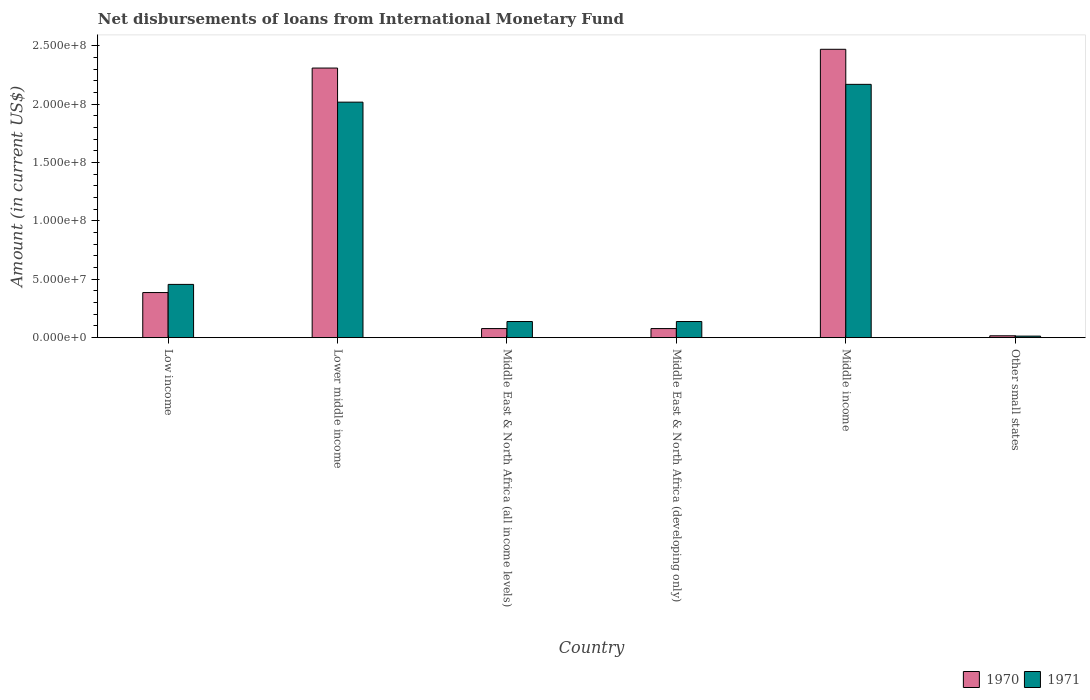How many different coloured bars are there?
Your response must be concise. 2. How many groups of bars are there?
Offer a very short reply. 6. Are the number of bars per tick equal to the number of legend labels?
Your answer should be very brief. Yes. Are the number of bars on each tick of the X-axis equal?
Ensure brevity in your answer.  Yes. How many bars are there on the 1st tick from the left?
Your answer should be compact. 2. How many bars are there on the 5th tick from the right?
Make the answer very short. 2. What is the label of the 6th group of bars from the left?
Make the answer very short. Other small states. What is the amount of loans disbursed in 1971 in Other small states?
Provide a succinct answer. 1.32e+06. Across all countries, what is the maximum amount of loans disbursed in 1970?
Your answer should be compact. 2.47e+08. Across all countries, what is the minimum amount of loans disbursed in 1970?
Give a very brief answer. 1.61e+06. In which country was the amount of loans disbursed in 1971 maximum?
Offer a very short reply. Middle income. In which country was the amount of loans disbursed in 1971 minimum?
Offer a very short reply. Other small states. What is the total amount of loans disbursed in 1971 in the graph?
Your answer should be compact. 4.93e+08. What is the difference between the amount of loans disbursed in 1971 in Middle East & North Africa (developing only) and that in Middle income?
Offer a terse response. -2.03e+08. What is the difference between the amount of loans disbursed in 1970 in Middle East & North Africa (developing only) and the amount of loans disbursed in 1971 in Lower middle income?
Your answer should be compact. -1.94e+08. What is the average amount of loans disbursed in 1971 per country?
Your answer should be very brief. 8.22e+07. What is the difference between the amount of loans disbursed of/in 1970 and amount of loans disbursed of/in 1971 in Lower middle income?
Your answer should be very brief. 2.92e+07. What is the ratio of the amount of loans disbursed in 1970 in Middle East & North Africa (all income levels) to that in Middle East & North Africa (developing only)?
Keep it short and to the point. 1. Is the amount of loans disbursed in 1971 in Middle East & North Africa (all income levels) less than that in Middle income?
Provide a succinct answer. Yes. What is the difference between the highest and the second highest amount of loans disbursed in 1970?
Your answer should be compact. 1.61e+07. What is the difference between the highest and the lowest amount of loans disbursed in 1970?
Your answer should be compact. 2.45e+08. Is the sum of the amount of loans disbursed in 1971 in Middle income and Other small states greater than the maximum amount of loans disbursed in 1970 across all countries?
Offer a very short reply. No. What does the 2nd bar from the left in Low income represents?
Your answer should be compact. 1971. Are all the bars in the graph horizontal?
Offer a very short reply. No. How many countries are there in the graph?
Your answer should be very brief. 6. Are the values on the major ticks of Y-axis written in scientific E-notation?
Provide a succinct answer. Yes. Does the graph contain any zero values?
Provide a succinct answer. No. Does the graph contain grids?
Keep it short and to the point. No. How many legend labels are there?
Provide a succinct answer. 2. How are the legend labels stacked?
Give a very brief answer. Horizontal. What is the title of the graph?
Your answer should be compact. Net disbursements of loans from International Monetary Fund. What is the label or title of the X-axis?
Make the answer very short. Country. What is the Amount (in current US$) of 1970 in Low income?
Your response must be concise. 3.86e+07. What is the Amount (in current US$) of 1971 in Low income?
Your answer should be very brief. 4.56e+07. What is the Amount (in current US$) of 1970 in Lower middle income?
Ensure brevity in your answer.  2.31e+08. What is the Amount (in current US$) of 1971 in Lower middle income?
Give a very brief answer. 2.02e+08. What is the Amount (in current US$) in 1970 in Middle East & North Africa (all income levels)?
Your answer should be compact. 7.79e+06. What is the Amount (in current US$) of 1971 in Middle East & North Africa (all income levels)?
Offer a terse response. 1.38e+07. What is the Amount (in current US$) of 1970 in Middle East & North Africa (developing only)?
Make the answer very short. 7.79e+06. What is the Amount (in current US$) in 1971 in Middle East & North Africa (developing only)?
Provide a short and direct response. 1.38e+07. What is the Amount (in current US$) in 1970 in Middle income?
Make the answer very short. 2.47e+08. What is the Amount (in current US$) of 1971 in Middle income?
Offer a very short reply. 2.17e+08. What is the Amount (in current US$) of 1970 in Other small states?
Your answer should be compact. 1.61e+06. What is the Amount (in current US$) of 1971 in Other small states?
Keep it short and to the point. 1.32e+06. Across all countries, what is the maximum Amount (in current US$) in 1970?
Your answer should be compact. 2.47e+08. Across all countries, what is the maximum Amount (in current US$) in 1971?
Your answer should be very brief. 2.17e+08. Across all countries, what is the minimum Amount (in current US$) in 1970?
Make the answer very short. 1.61e+06. Across all countries, what is the minimum Amount (in current US$) of 1971?
Make the answer very short. 1.32e+06. What is the total Amount (in current US$) in 1970 in the graph?
Your response must be concise. 5.34e+08. What is the total Amount (in current US$) of 1971 in the graph?
Your answer should be very brief. 4.93e+08. What is the difference between the Amount (in current US$) of 1970 in Low income and that in Lower middle income?
Offer a terse response. -1.92e+08. What is the difference between the Amount (in current US$) in 1971 in Low income and that in Lower middle income?
Make the answer very short. -1.56e+08. What is the difference between the Amount (in current US$) in 1970 in Low income and that in Middle East & North Africa (all income levels)?
Give a very brief answer. 3.08e+07. What is the difference between the Amount (in current US$) in 1971 in Low income and that in Middle East & North Africa (all income levels)?
Your answer should be very brief. 3.18e+07. What is the difference between the Amount (in current US$) in 1970 in Low income and that in Middle East & North Africa (developing only)?
Keep it short and to the point. 3.08e+07. What is the difference between the Amount (in current US$) of 1971 in Low income and that in Middle East & North Africa (developing only)?
Ensure brevity in your answer.  3.18e+07. What is the difference between the Amount (in current US$) in 1970 in Low income and that in Middle income?
Your answer should be very brief. -2.08e+08. What is the difference between the Amount (in current US$) in 1971 in Low income and that in Middle income?
Your answer should be compact. -1.71e+08. What is the difference between the Amount (in current US$) of 1970 in Low income and that in Other small states?
Give a very brief answer. 3.70e+07. What is the difference between the Amount (in current US$) in 1971 in Low income and that in Other small states?
Offer a terse response. 4.43e+07. What is the difference between the Amount (in current US$) in 1970 in Lower middle income and that in Middle East & North Africa (all income levels)?
Keep it short and to the point. 2.23e+08. What is the difference between the Amount (in current US$) in 1971 in Lower middle income and that in Middle East & North Africa (all income levels)?
Keep it short and to the point. 1.88e+08. What is the difference between the Amount (in current US$) of 1970 in Lower middle income and that in Middle East & North Africa (developing only)?
Your answer should be compact. 2.23e+08. What is the difference between the Amount (in current US$) in 1971 in Lower middle income and that in Middle East & North Africa (developing only)?
Your response must be concise. 1.88e+08. What is the difference between the Amount (in current US$) of 1970 in Lower middle income and that in Middle income?
Your answer should be very brief. -1.61e+07. What is the difference between the Amount (in current US$) in 1971 in Lower middle income and that in Middle income?
Your answer should be compact. -1.52e+07. What is the difference between the Amount (in current US$) of 1970 in Lower middle income and that in Other small states?
Offer a very short reply. 2.29e+08. What is the difference between the Amount (in current US$) of 1971 in Lower middle income and that in Other small states?
Offer a terse response. 2.00e+08. What is the difference between the Amount (in current US$) in 1970 in Middle East & North Africa (all income levels) and that in Middle income?
Make the answer very short. -2.39e+08. What is the difference between the Amount (in current US$) of 1971 in Middle East & North Africa (all income levels) and that in Middle income?
Keep it short and to the point. -2.03e+08. What is the difference between the Amount (in current US$) of 1970 in Middle East & North Africa (all income levels) and that in Other small states?
Ensure brevity in your answer.  6.19e+06. What is the difference between the Amount (in current US$) in 1971 in Middle East & North Africa (all income levels) and that in Other small states?
Your answer should be compact. 1.25e+07. What is the difference between the Amount (in current US$) of 1970 in Middle East & North Africa (developing only) and that in Middle income?
Provide a succinct answer. -2.39e+08. What is the difference between the Amount (in current US$) in 1971 in Middle East & North Africa (developing only) and that in Middle income?
Offer a very short reply. -2.03e+08. What is the difference between the Amount (in current US$) in 1970 in Middle East & North Africa (developing only) and that in Other small states?
Your answer should be compact. 6.19e+06. What is the difference between the Amount (in current US$) of 1971 in Middle East & North Africa (developing only) and that in Other small states?
Your response must be concise. 1.25e+07. What is the difference between the Amount (in current US$) in 1970 in Middle income and that in Other small states?
Provide a succinct answer. 2.45e+08. What is the difference between the Amount (in current US$) of 1971 in Middle income and that in Other small states?
Provide a short and direct response. 2.16e+08. What is the difference between the Amount (in current US$) in 1970 in Low income and the Amount (in current US$) in 1971 in Lower middle income?
Provide a succinct answer. -1.63e+08. What is the difference between the Amount (in current US$) of 1970 in Low income and the Amount (in current US$) of 1971 in Middle East & North Africa (all income levels)?
Offer a terse response. 2.48e+07. What is the difference between the Amount (in current US$) of 1970 in Low income and the Amount (in current US$) of 1971 in Middle East & North Africa (developing only)?
Offer a very short reply. 2.48e+07. What is the difference between the Amount (in current US$) of 1970 in Low income and the Amount (in current US$) of 1971 in Middle income?
Ensure brevity in your answer.  -1.78e+08. What is the difference between the Amount (in current US$) in 1970 in Low income and the Amount (in current US$) in 1971 in Other small states?
Provide a short and direct response. 3.73e+07. What is the difference between the Amount (in current US$) in 1970 in Lower middle income and the Amount (in current US$) in 1971 in Middle East & North Africa (all income levels)?
Offer a terse response. 2.17e+08. What is the difference between the Amount (in current US$) in 1970 in Lower middle income and the Amount (in current US$) in 1971 in Middle East & North Africa (developing only)?
Give a very brief answer. 2.17e+08. What is the difference between the Amount (in current US$) in 1970 in Lower middle income and the Amount (in current US$) in 1971 in Middle income?
Your response must be concise. 1.40e+07. What is the difference between the Amount (in current US$) in 1970 in Lower middle income and the Amount (in current US$) in 1971 in Other small states?
Provide a short and direct response. 2.30e+08. What is the difference between the Amount (in current US$) of 1970 in Middle East & North Africa (all income levels) and the Amount (in current US$) of 1971 in Middle East & North Africa (developing only)?
Provide a short and direct response. -6.03e+06. What is the difference between the Amount (in current US$) of 1970 in Middle East & North Africa (all income levels) and the Amount (in current US$) of 1971 in Middle income?
Offer a terse response. -2.09e+08. What is the difference between the Amount (in current US$) in 1970 in Middle East & North Africa (all income levels) and the Amount (in current US$) in 1971 in Other small states?
Your response must be concise. 6.47e+06. What is the difference between the Amount (in current US$) of 1970 in Middle East & North Africa (developing only) and the Amount (in current US$) of 1971 in Middle income?
Offer a very short reply. -2.09e+08. What is the difference between the Amount (in current US$) in 1970 in Middle East & North Africa (developing only) and the Amount (in current US$) in 1971 in Other small states?
Make the answer very short. 6.47e+06. What is the difference between the Amount (in current US$) of 1970 in Middle income and the Amount (in current US$) of 1971 in Other small states?
Make the answer very short. 2.46e+08. What is the average Amount (in current US$) of 1970 per country?
Give a very brief answer. 8.90e+07. What is the average Amount (in current US$) of 1971 per country?
Give a very brief answer. 8.22e+07. What is the difference between the Amount (in current US$) of 1970 and Amount (in current US$) of 1971 in Low income?
Offer a very short reply. -6.99e+06. What is the difference between the Amount (in current US$) in 1970 and Amount (in current US$) in 1971 in Lower middle income?
Your answer should be compact. 2.92e+07. What is the difference between the Amount (in current US$) in 1970 and Amount (in current US$) in 1971 in Middle East & North Africa (all income levels)?
Your response must be concise. -6.03e+06. What is the difference between the Amount (in current US$) of 1970 and Amount (in current US$) of 1971 in Middle East & North Africa (developing only)?
Offer a very short reply. -6.03e+06. What is the difference between the Amount (in current US$) of 1970 and Amount (in current US$) of 1971 in Middle income?
Keep it short and to the point. 3.00e+07. What is the difference between the Amount (in current US$) of 1970 and Amount (in current US$) of 1971 in Other small states?
Make the answer very short. 2.85e+05. What is the ratio of the Amount (in current US$) in 1970 in Low income to that in Lower middle income?
Offer a very short reply. 0.17. What is the ratio of the Amount (in current US$) of 1971 in Low income to that in Lower middle income?
Provide a succinct answer. 0.23. What is the ratio of the Amount (in current US$) in 1970 in Low income to that in Middle East & North Africa (all income levels)?
Your response must be concise. 4.96. What is the ratio of the Amount (in current US$) in 1971 in Low income to that in Middle East & North Africa (all income levels)?
Ensure brevity in your answer.  3.3. What is the ratio of the Amount (in current US$) in 1970 in Low income to that in Middle East & North Africa (developing only)?
Your answer should be very brief. 4.96. What is the ratio of the Amount (in current US$) of 1971 in Low income to that in Middle East & North Africa (developing only)?
Ensure brevity in your answer.  3.3. What is the ratio of the Amount (in current US$) in 1970 in Low income to that in Middle income?
Give a very brief answer. 0.16. What is the ratio of the Amount (in current US$) of 1971 in Low income to that in Middle income?
Give a very brief answer. 0.21. What is the ratio of the Amount (in current US$) of 1970 in Low income to that in Other small states?
Provide a succinct answer. 24.04. What is the ratio of the Amount (in current US$) in 1971 in Low income to that in Other small states?
Offer a very short reply. 34.52. What is the ratio of the Amount (in current US$) in 1970 in Lower middle income to that in Middle East & North Africa (all income levels)?
Make the answer very short. 29.63. What is the ratio of the Amount (in current US$) of 1971 in Lower middle income to that in Middle East & North Africa (all income levels)?
Provide a short and direct response. 14.6. What is the ratio of the Amount (in current US$) in 1970 in Lower middle income to that in Middle East & North Africa (developing only)?
Your answer should be compact. 29.63. What is the ratio of the Amount (in current US$) of 1971 in Lower middle income to that in Middle East & North Africa (developing only)?
Keep it short and to the point. 14.6. What is the ratio of the Amount (in current US$) of 1970 in Lower middle income to that in Middle income?
Offer a very short reply. 0.93. What is the ratio of the Amount (in current US$) of 1971 in Lower middle income to that in Middle income?
Your answer should be very brief. 0.93. What is the ratio of the Amount (in current US$) in 1970 in Lower middle income to that in Other small states?
Your response must be concise. 143.71. What is the ratio of the Amount (in current US$) of 1971 in Lower middle income to that in Other small states?
Your response must be concise. 152.6. What is the ratio of the Amount (in current US$) in 1970 in Middle East & North Africa (all income levels) to that in Middle East & North Africa (developing only)?
Your answer should be compact. 1. What is the ratio of the Amount (in current US$) in 1971 in Middle East & North Africa (all income levels) to that in Middle East & North Africa (developing only)?
Keep it short and to the point. 1. What is the ratio of the Amount (in current US$) of 1970 in Middle East & North Africa (all income levels) to that in Middle income?
Provide a short and direct response. 0.03. What is the ratio of the Amount (in current US$) in 1971 in Middle East & North Africa (all income levels) to that in Middle income?
Ensure brevity in your answer.  0.06. What is the ratio of the Amount (in current US$) of 1970 in Middle East & North Africa (all income levels) to that in Other small states?
Ensure brevity in your answer.  4.85. What is the ratio of the Amount (in current US$) in 1971 in Middle East & North Africa (all income levels) to that in Other small states?
Provide a short and direct response. 10.45. What is the ratio of the Amount (in current US$) of 1970 in Middle East & North Africa (developing only) to that in Middle income?
Keep it short and to the point. 0.03. What is the ratio of the Amount (in current US$) in 1971 in Middle East & North Africa (developing only) to that in Middle income?
Make the answer very short. 0.06. What is the ratio of the Amount (in current US$) in 1970 in Middle East & North Africa (developing only) to that in Other small states?
Offer a very short reply. 4.85. What is the ratio of the Amount (in current US$) in 1971 in Middle East & North Africa (developing only) to that in Other small states?
Your response must be concise. 10.45. What is the ratio of the Amount (in current US$) of 1970 in Middle income to that in Other small states?
Offer a terse response. 153.71. What is the ratio of the Amount (in current US$) of 1971 in Middle income to that in Other small states?
Provide a succinct answer. 164.14. What is the difference between the highest and the second highest Amount (in current US$) of 1970?
Offer a terse response. 1.61e+07. What is the difference between the highest and the second highest Amount (in current US$) in 1971?
Give a very brief answer. 1.52e+07. What is the difference between the highest and the lowest Amount (in current US$) in 1970?
Keep it short and to the point. 2.45e+08. What is the difference between the highest and the lowest Amount (in current US$) in 1971?
Provide a succinct answer. 2.16e+08. 